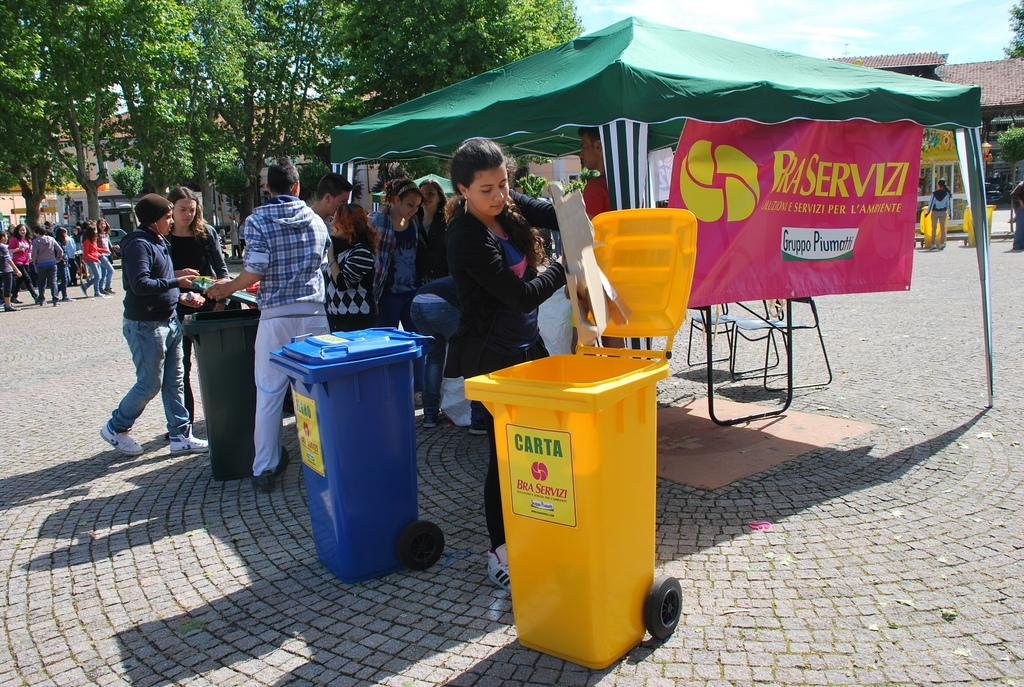Provide a one-sentence caption for the provided image. A woman empties some trash into the Bra Servizi trash can. 